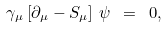Convert formula to latex. <formula><loc_0><loc_0><loc_500><loc_500>\gamma _ { \mu } \left [ { \partial _ { \mu } - S _ { \mu } } \right ] \, \psi \ = \ 0 ,</formula> 